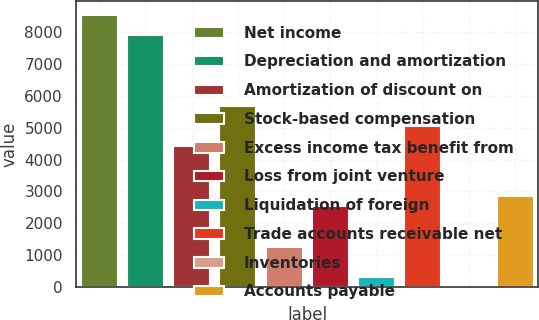Convert chart to OTSL. <chart><loc_0><loc_0><loc_500><loc_500><bar_chart><fcel>Net income<fcel>Depreciation and amortization<fcel>Amortization of discount on<fcel>Stock-based compensation<fcel>Excess income tax benefit from<fcel>Loss from joint venture<fcel>Liquidation of foreign<fcel>Trade accounts receivable net<fcel>Inventories<fcel>Accounts payable<nl><fcel>8534<fcel>7902<fcel>4426<fcel>5690<fcel>1266<fcel>2530<fcel>318<fcel>5058<fcel>2<fcel>2846<nl></chart> 